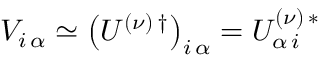<formula> <loc_0><loc_0><loc_500><loc_500>V _ { i \, \alpha } \simeq \left ( U ^ { ( \nu ) \, \dagger } \right ) _ { i \, \alpha } = U _ { \alpha \, i } ^ { ( \nu ) \, * }</formula> 